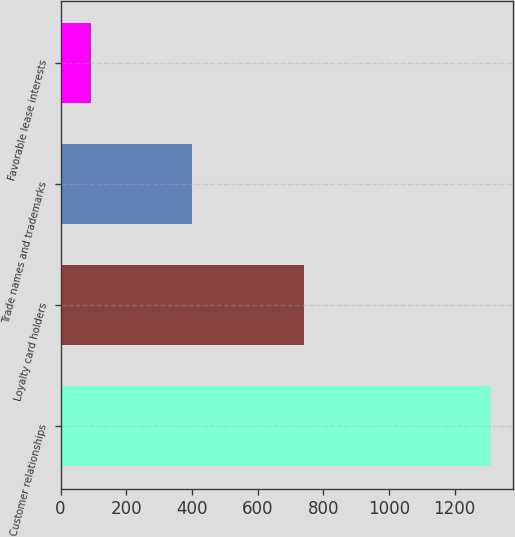Convert chart. <chart><loc_0><loc_0><loc_500><loc_500><bar_chart><fcel>Customer relationships<fcel>Loyalty card holders<fcel>Trade names and trademarks<fcel>Favorable lease interests<nl><fcel>1311<fcel>742<fcel>399<fcel>93<nl></chart> 